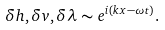Convert formula to latex. <formula><loc_0><loc_0><loc_500><loc_500>\delta h , \delta v , \delta \lambda \sim e ^ { i ( k x - \omega t ) } .</formula> 